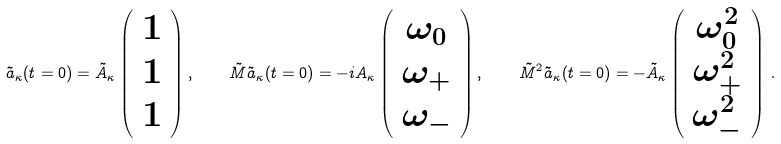<formula> <loc_0><loc_0><loc_500><loc_500>\tilde { a } _ { \kappa } ( t = 0 ) = \tilde { A } _ { \kappa } \left ( \begin{array} { c } 1 \\ 1 \\ 1 \end{array} \right ) , \quad \tilde { M } \tilde { a } _ { \kappa } ( t = 0 ) = - i A _ { \kappa } \left ( \begin{array} { c } \omega _ { 0 } \\ \omega _ { + } \\ \omega _ { - } \end{array} \right ) , \quad \tilde { M } ^ { 2 } \tilde { a } _ { \kappa } ( t = 0 ) = - \tilde { A } _ { \kappa } \left ( \begin{array} { c } \omega _ { 0 } ^ { 2 } \\ \omega _ { + } ^ { 2 } \\ \omega _ { - } ^ { 2 } \end{array} \right ) \, .</formula> 